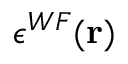Convert formula to latex. <formula><loc_0><loc_0><loc_500><loc_500>\epsilon ^ { W F } ( r )</formula> 